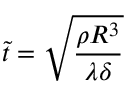<formula> <loc_0><loc_0><loc_500><loc_500>\tilde { t } = \sqrt { \frac { \rho R ^ { 3 } } { \lambda \delta } }</formula> 